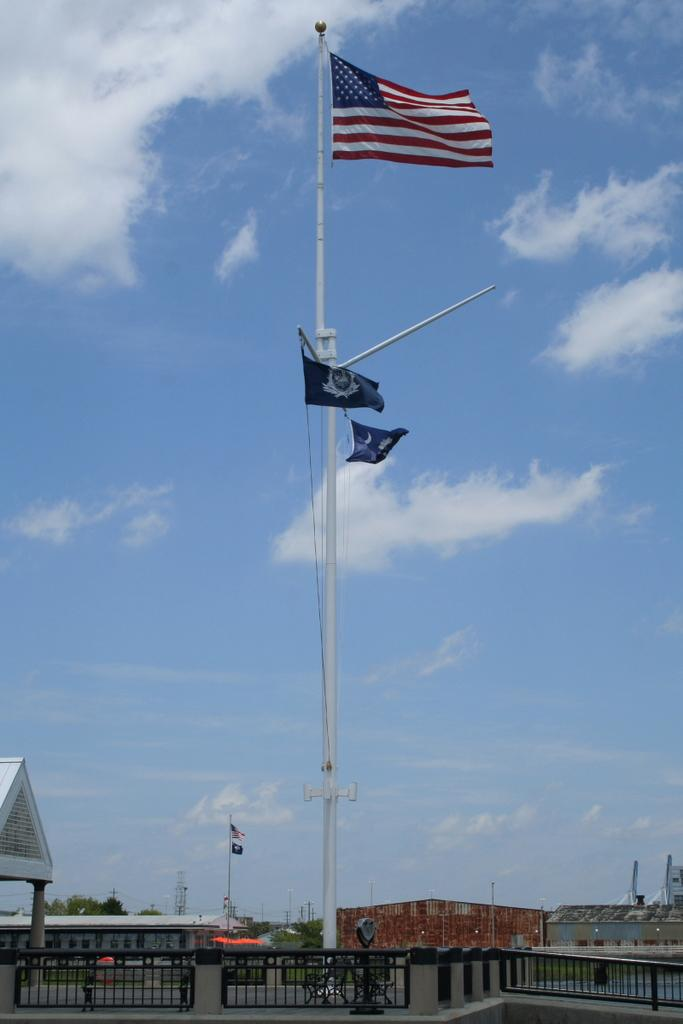What type of structure can be seen in the image? There is a railing in the image. What is located near the railing? There is a flagpole in the image. What can be seen in the background of the image? There are houses, a flagpole, trees, and the sky visible in the background of the image. How many locks can be seen on the railing in the image? There are no locks visible on the railing in the image. What type of lizards can be seen climbing the flagpole in the image? There are no lizards present in the image, and the flagpole is not depicted as having any climbing creatures. 